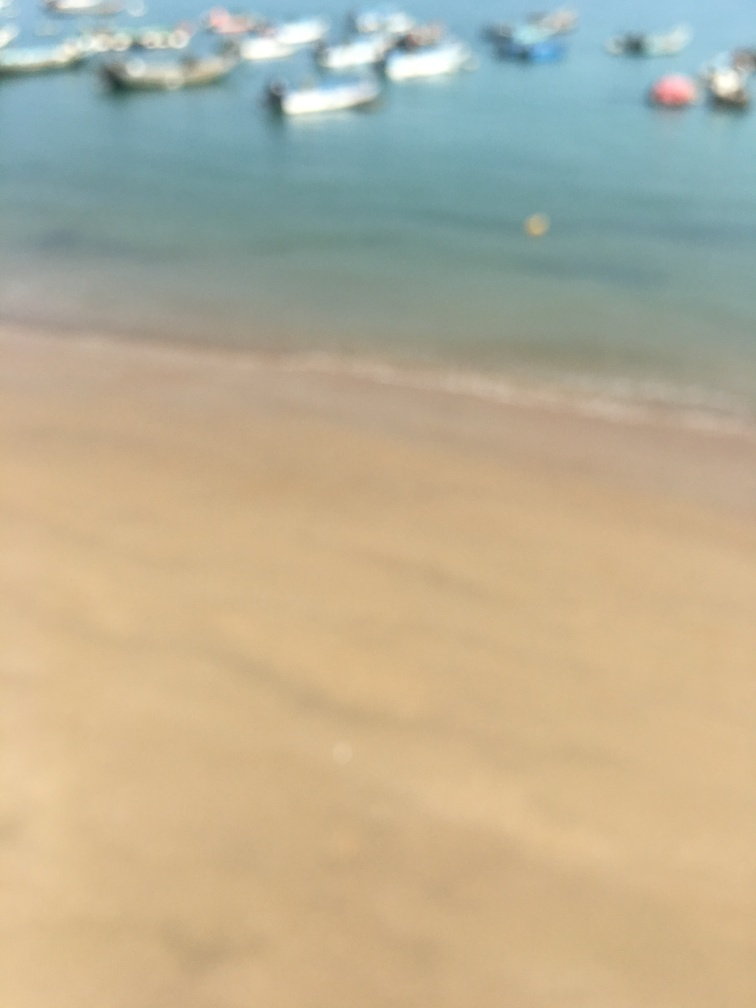What activities might people be doing in this blurred beach scene? Given the context of the beach and the presence of boats, people might be engaged in activities like sunbathing, swimming, boating, or possibly playing beach sports. 